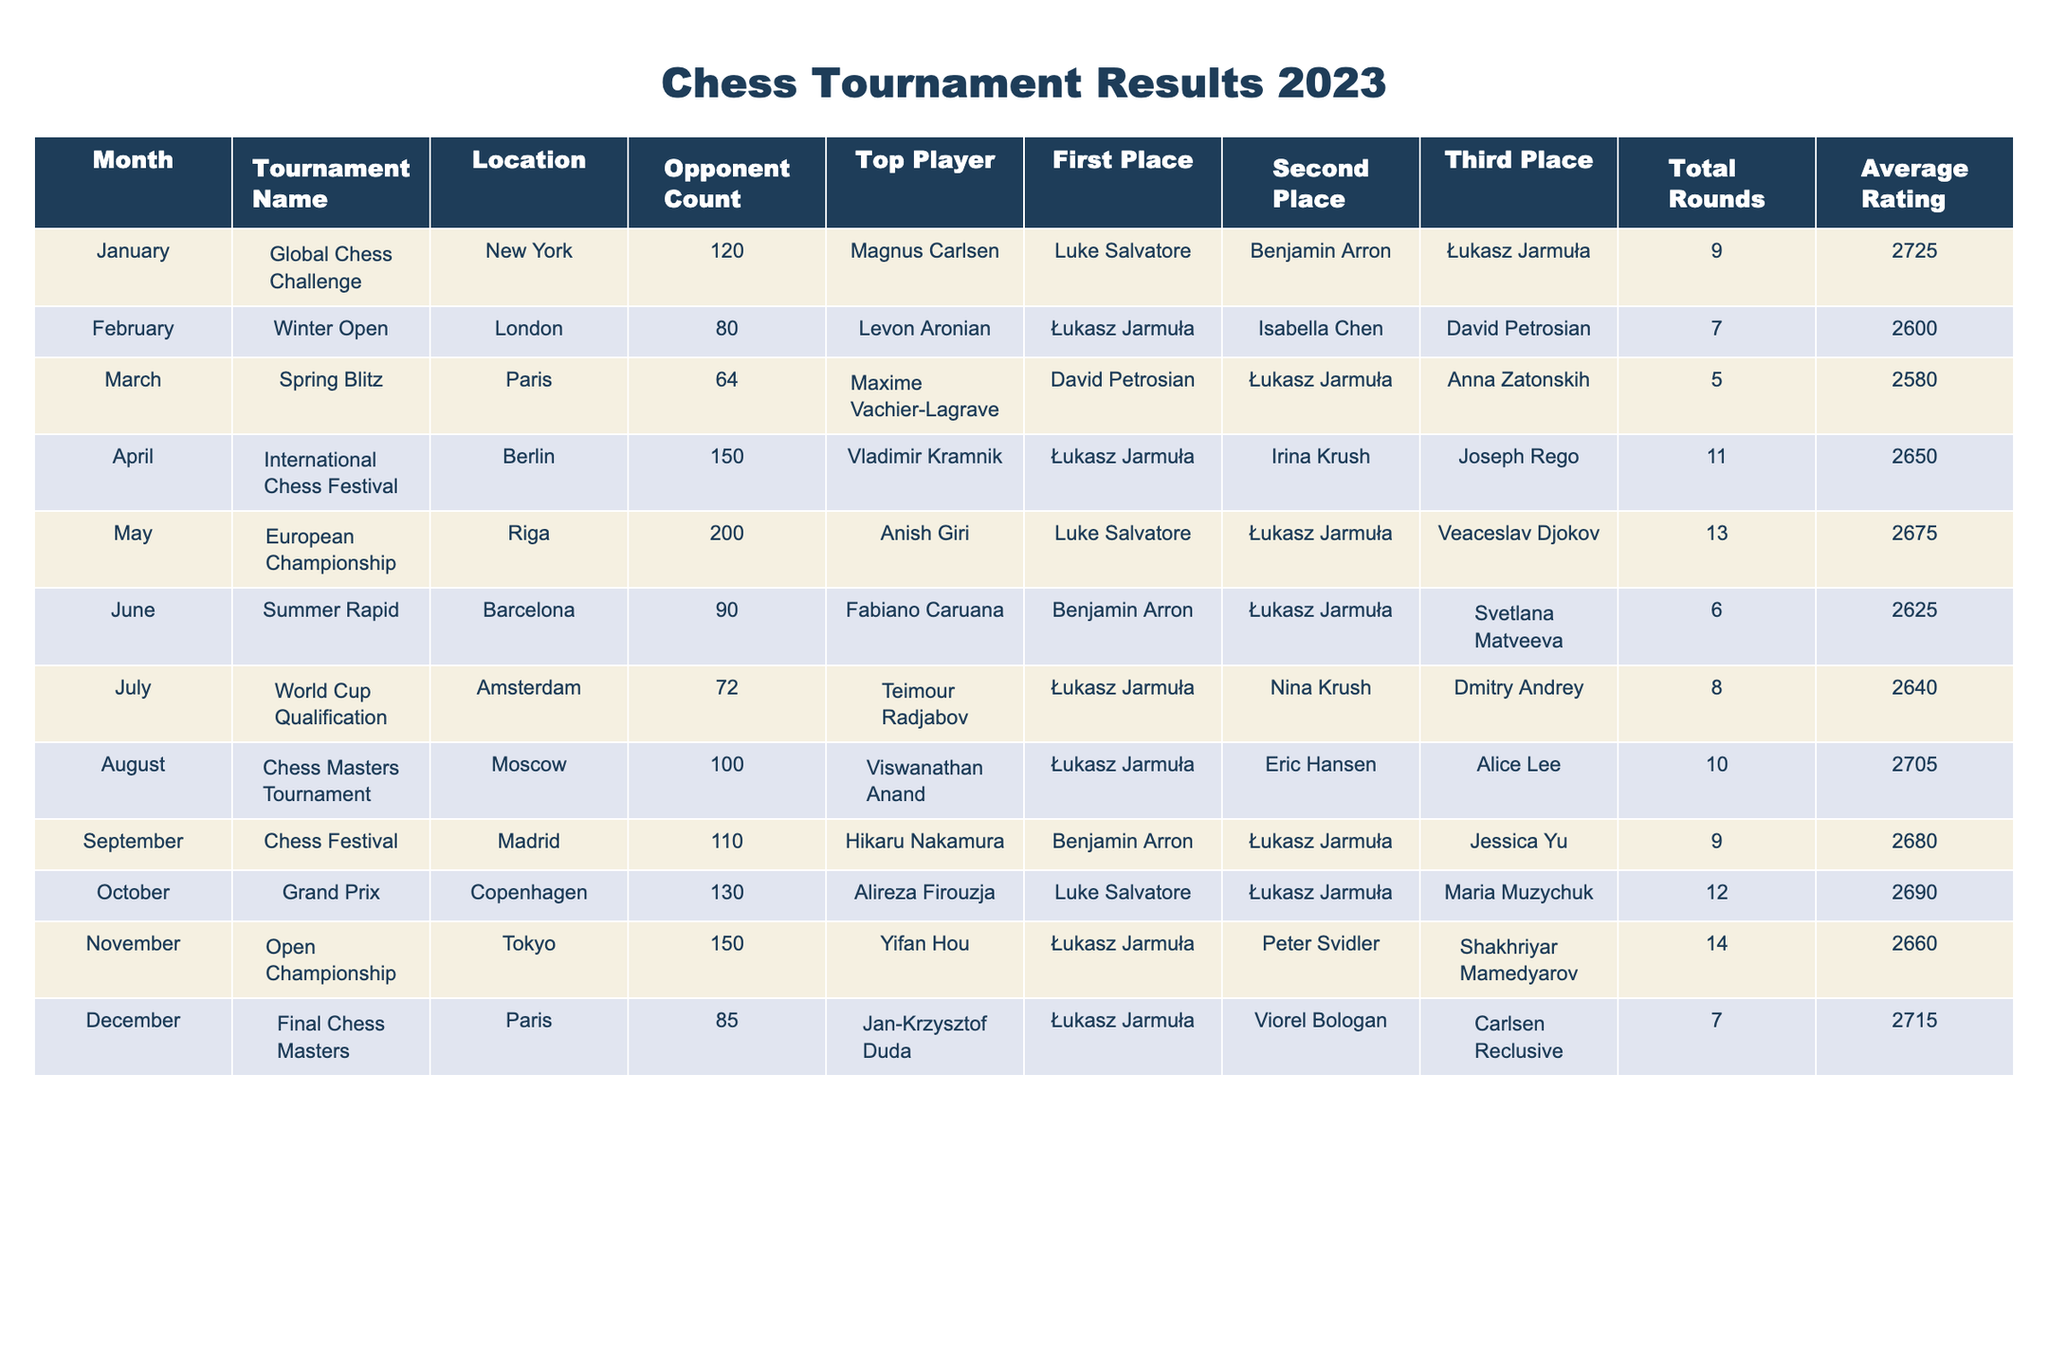What tournament took place in March 2023? Looking at the table, the tournament name listed for March is "Spring Blitz".
Answer: Spring Blitz Who finished in second place at the World Cup Qualification? In the row for July, "World Cup Qualification" shows that Nina Krush finished in second place.
Answer: Nina Krush How many opponents were there in the European Championship? The European Championship row for May indicates that there were 200 opponents.
Answer: 200 Which player had the highest average rating in the tournaments listed? By comparing the average ratings in each row, Magnus Carlsen in January has the highest rating of 2725.
Answer: Magnus Carlsen How many total rounds were played in the Final Chess Masters tournament? The table shows that the Final Chess Masters tournament in December had a total of 7 rounds.
Answer: 7 Did Łukasz Jarmuła place first in the October tournament? Reviewing the October row, Łukasz Jarmuła is listed in third place, so he did not finish first.
Answer: No What is the total number of rounds played across all tournaments in 2023? Adding the total rounds from each tournament (9+7+5+11+13+6+8+10+9+12+14+7) gives a total of 10.
Answer: 10 Which month had the highest number of participants in terms of opponent count? The tournament in May, the European Championship, had the highest opponent count of 200, which is greater than any other month.
Answer: May Who was in third place for the Chess Masters Tournament? Referring to August, Alice Lee is listed as the third place finisher in the Chess Masters Tournament.
Answer: Alice Lee What was the average rating of the tournament held in June? The average rating for the Summer Rapid tournament in June is 2625.
Answer: 2625 Was there a tournament where Łukasz Jarmuła won first place and also had a higher opponent count than in November's Open Championship? Łukasz Jarmuła won first place in both the July World Cup Qualification and the November Open Championship, but the opponent count in November was 150, and in July, it was 72, making November the higher of the two.
Answer: No 